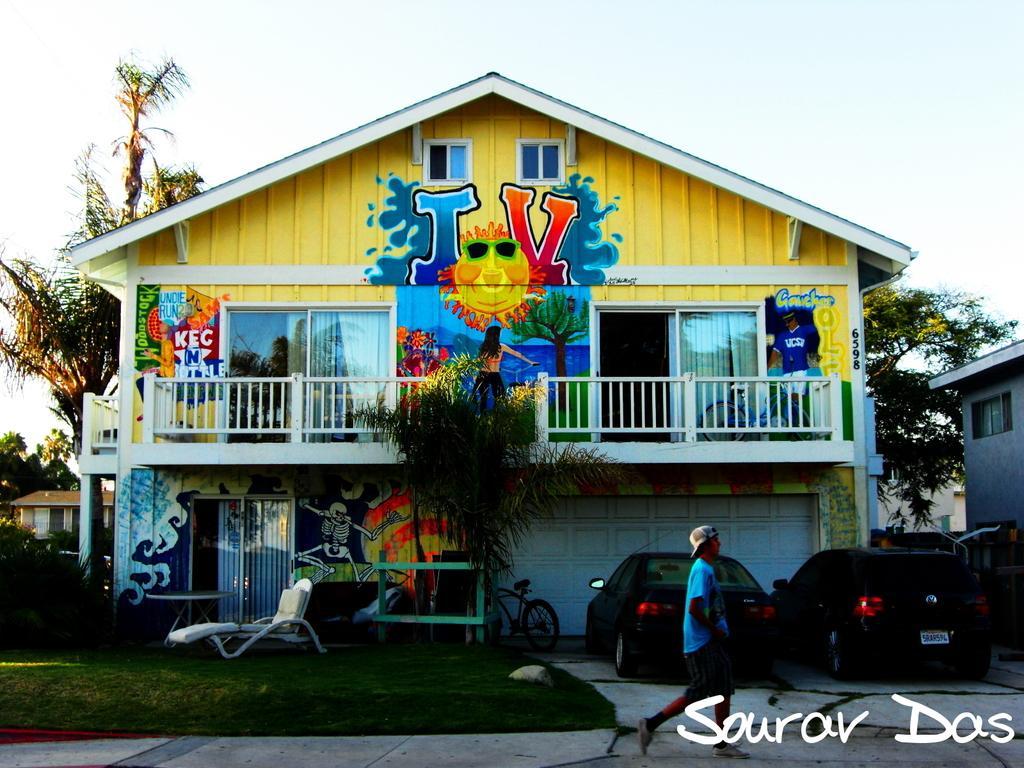Describe this image in one or two sentences. In this image in the middle, there is a house on that there are windows, doors, curtains, text, wall paint and some people. At the bottom there is a man, he wears a blue t shirt, trouser and cap, he is walking and there is a text. At the bottom there are cars, grass, chair, trees. On the right there is a house. In the background there is sky. 